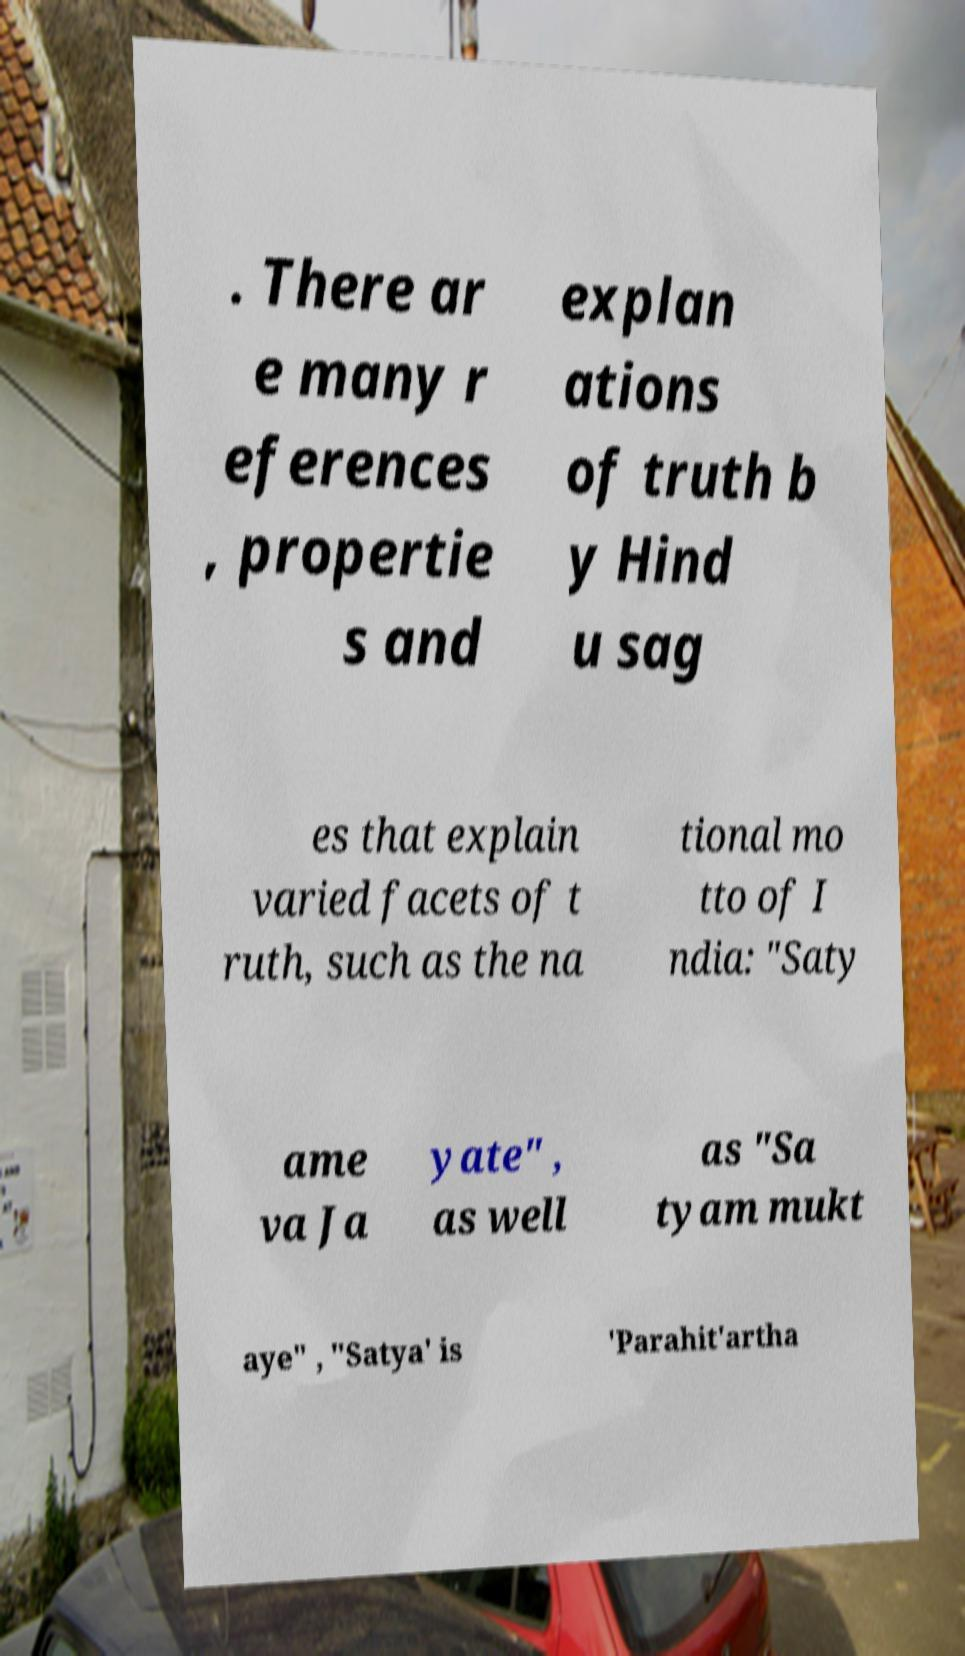Can you accurately transcribe the text from the provided image for me? . There ar e many r eferences , propertie s and explan ations of truth b y Hind u sag es that explain varied facets of t ruth, such as the na tional mo tto of I ndia: "Saty ame va Ja yate" , as well as "Sa tyam mukt aye" , "Satya' is 'Parahit'artha 